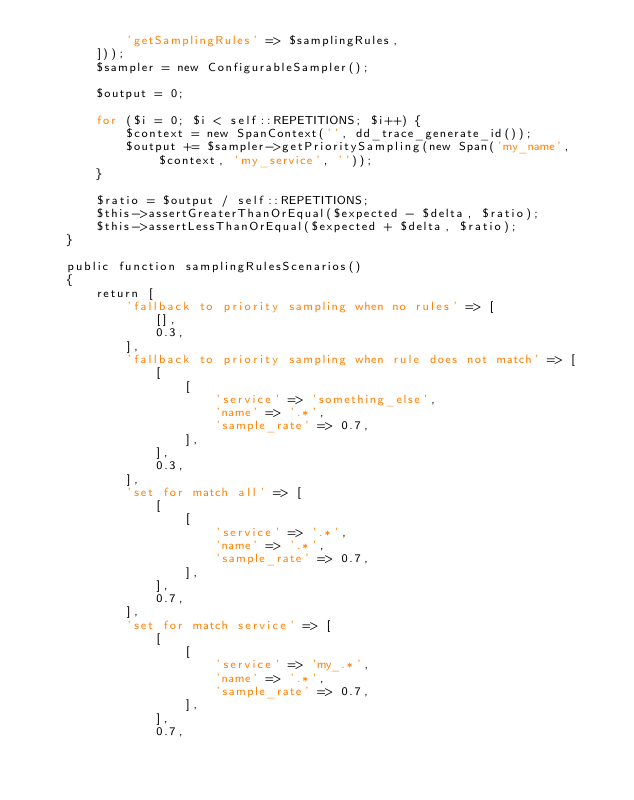Convert code to text. <code><loc_0><loc_0><loc_500><loc_500><_PHP_>            'getSamplingRules' => $samplingRules,
        ]));
        $sampler = new ConfigurableSampler();

        $output = 0;

        for ($i = 0; $i < self::REPETITIONS; $i++) {
            $context = new SpanContext('', dd_trace_generate_id());
            $output += $sampler->getPrioritySampling(new Span('my_name', $context, 'my_service', ''));
        }

        $ratio = $output / self::REPETITIONS;
        $this->assertGreaterThanOrEqual($expected - $delta, $ratio);
        $this->assertLessThanOrEqual($expected + $delta, $ratio);
    }

    public function samplingRulesScenarios()
    {
        return [
            'fallback to priority sampling when no rules' => [
                [],
                0.3,
            ],
            'fallback to priority sampling when rule does not match' => [
                [
                    [
                        'service' => 'something_else',
                        'name' => '.*',
                        'sample_rate' => 0.7,
                    ],
                ],
                0.3,
            ],
            'set for match all' => [
                [
                    [
                        'service' => '.*',
                        'name' => '.*',
                        'sample_rate' => 0.7,
                    ],
                ],
                0.7,
            ],
            'set for match service' => [
                [
                    [
                        'service' => 'my_.*',
                        'name' => '.*',
                        'sample_rate' => 0.7,
                    ],
                ],
                0.7,</code> 